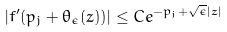<formula> <loc_0><loc_0><loc_500><loc_500>| f ^ { \prime } ( p _ { j } + \theta _ { \epsilon } ( z ) ) | \leq C e ^ { - p _ { j } + \sqrt { \epsilon } | z | }</formula> 